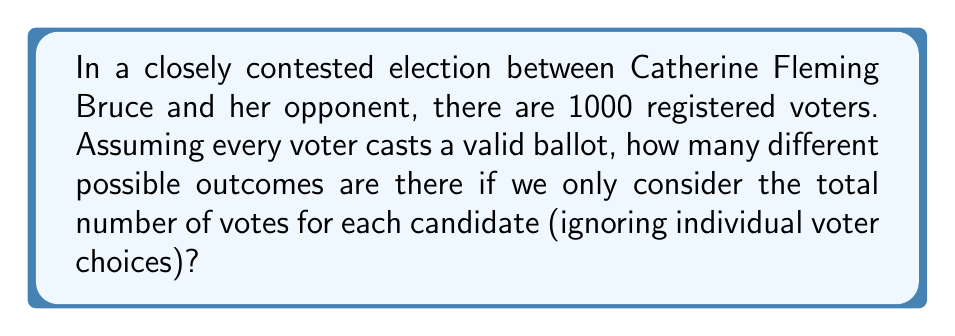Give your solution to this math problem. Let's approach this step-by-step:

1) First, we need to understand what the question is asking. We're looking for the number of ways the 1000 votes can be distributed between the two candidates.

2) This is essentially asking how many ways we can choose the number of votes for Catherine Fleming Bruce (or her opponent), as the other candidate's votes will be the remainder.

3) The number of votes Catherine Fleming Bruce can get ranges from 0 to 1000.

4) This can be represented mathematically as choosing a number from the set $\{0, 1, 2, ..., 999, 1000\}$.

5) The number of elements in this set is 1001.

6) Therefore, there are 1001 possible outcomes.

7) We can also think about this combinatorially:
   This is equivalent to the number of ways to choose Catherine Fleming Bruce's voters from 1000 people, which is:

   $$\sum_{k=0}^{1000} \binom{1000}{k} = 2^{1000}$$

   However, we're only interested in the total number of votes, not who specifically voted for whom. So each outcome in our scenario corresponds to many outcomes in this larger space.

8) The simpler way to count it is as we did in steps 1-6.
Answer: 1001 